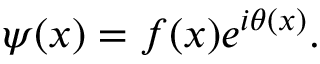<formula> <loc_0><loc_0><loc_500><loc_500>\psi ( x ) = f ( x ) e ^ { i \theta ( x ) } .</formula> 